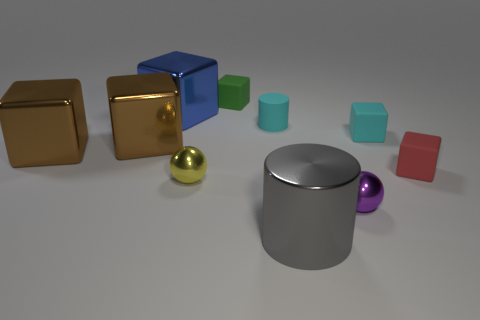Subtract all brown cubes. How many were subtracted if there are1brown cubes left? 1 Subtract all cylinders. How many objects are left? 8 Subtract 3 cubes. How many cubes are left? 3 Subtract all gray balls. Subtract all purple cubes. How many balls are left? 2 Subtract all purple balls. How many cyan blocks are left? 1 Subtract all tiny purple spheres. Subtract all small green cubes. How many objects are left? 8 Add 9 small green rubber things. How many small green rubber things are left? 10 Add 10 green rubber cylinders. How many green rubber cylinders exist? 10 Subtract all yellow balls. How many balls are left? 1 Subtract all red blocks. How many blocks are left? 5 